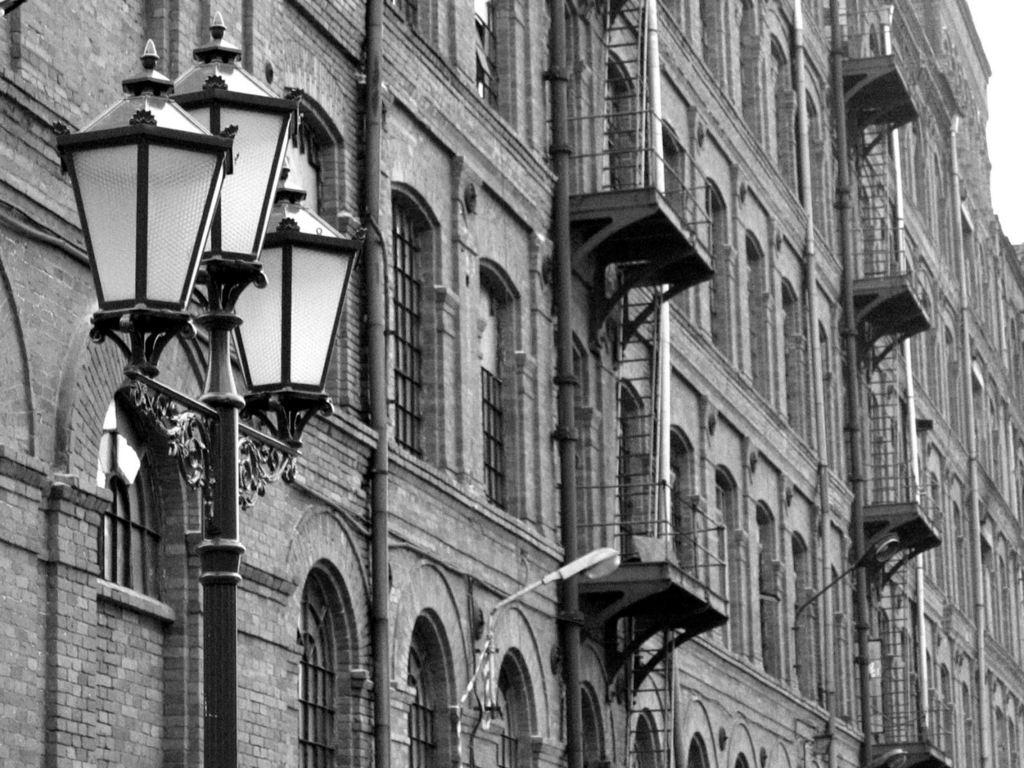What type of structure is present in the image? There is a building in the image. What can be seen on the left side of the image? There is a pole with three lights on the left side of the image. What is the color scheme of the image? The image is black and white. What part of the sky is visible in the image? The sky is visible at the top right side of the image. How many dogs are playing with a card on vacation in the image? There are no dogs, cards, or references to vacation in the image. 